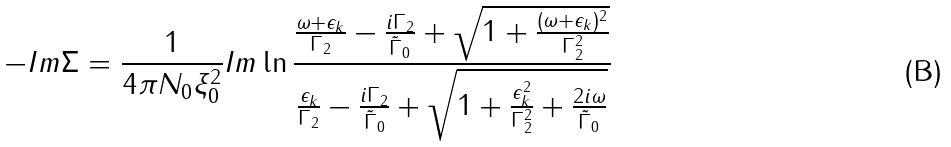<formula> <loc_0><loc_0><loc_500><loc_500>- I m \Sigma = \frac { 1 } { 4 \pi N _ { 0 } \xi _ { 0 } ^ { 2 } } I m \ln \frac { \frac { \omega + \epsilon _ { k } } { \Gamma _ { 2 } } - \frac { i \Gamma _ { 2 } } { \tilde { \Gamma } _ { 0 } } + \sqrt { 1 + \frac { ( \omega + \epsilon _ { k } ) ^ { 2 } } { \Gamma _ { 2 } ^ { 2 } } } } { \frac { \epsilon _ { k } } { \Gamma _ { 2 } } - \frac { i \Gamma _ { 2 } } { \tilde { \Gamma } _ { 0 } } + \sqrt { 1 + \frac { \epsilon _ { k } ^ { 2 } } { \Gamma _ { 2 } ^ { 2 } } + \frac { 2 i \omega } { \tilde { \Gamma } _ { 0 } } } }</formula> 